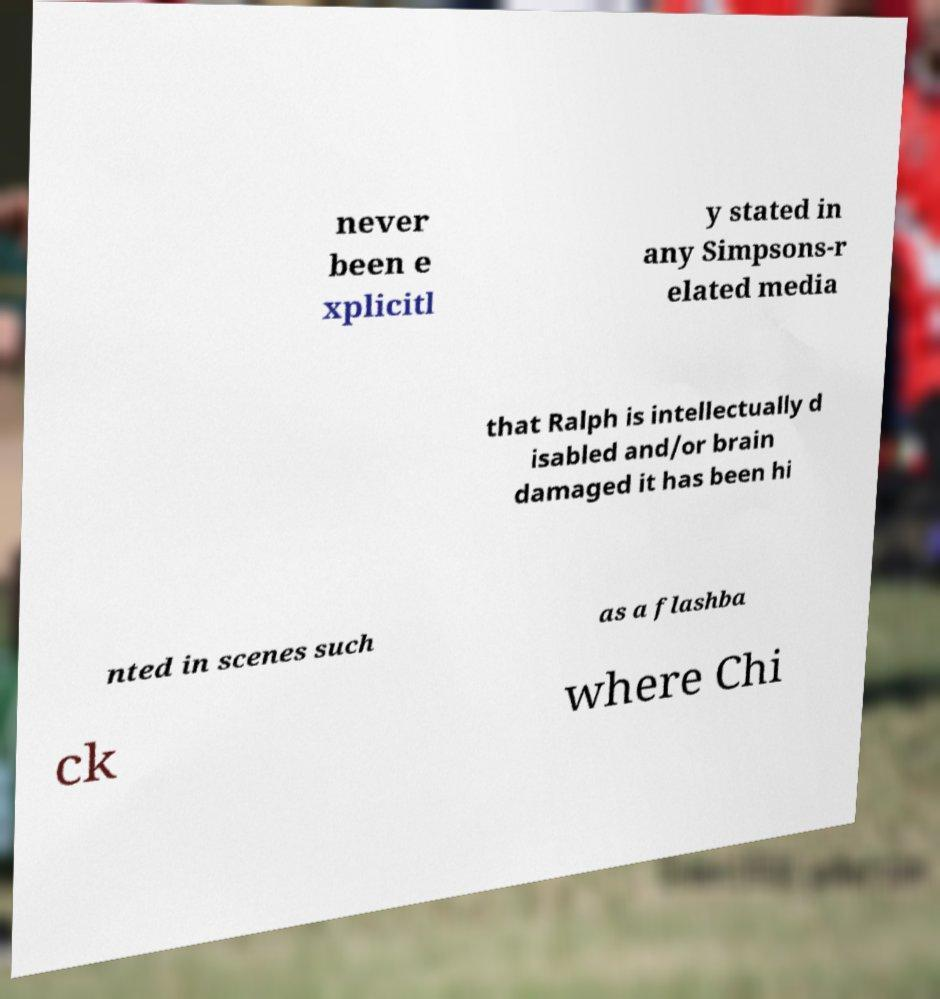Can you read and provide the text displayed in the image?This photo seems to have some interesting text. Can you extract and type it out for me? never been e xplicitl y stated in any Simpsons-r elated media that Ralph is intellectually d isabled and/or brain damaged it has been hi nted in scenes such as a flashba ck where Chi 